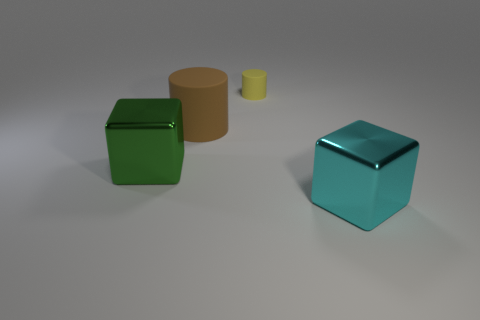Add 4 tiny blue metal balls. How many objects exist? 8 Subtract all yellow matte objects. Subtract all large metal things. How many objects are left? 1 Add 1 metal objects. How many metal objects are left? 3 Add 2 big cylinders. How many big cylinders exist? 3 Subtract 0 gray cylinders. How many objects are left? 4 